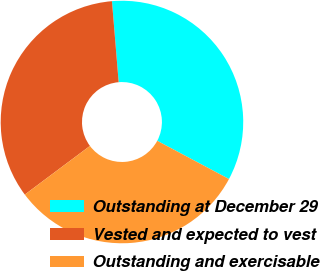Convert chart. <chart><loc_0><loc_0><loc_500><loc_500><pie_chart><fcel>Outstanding at December 29<fcel>Vested and expected to vest<fcel>Outstanding and exercisable<nl><fcel>34.11%<fcel>33.9%<fcel>32.0%<nl></chart> 